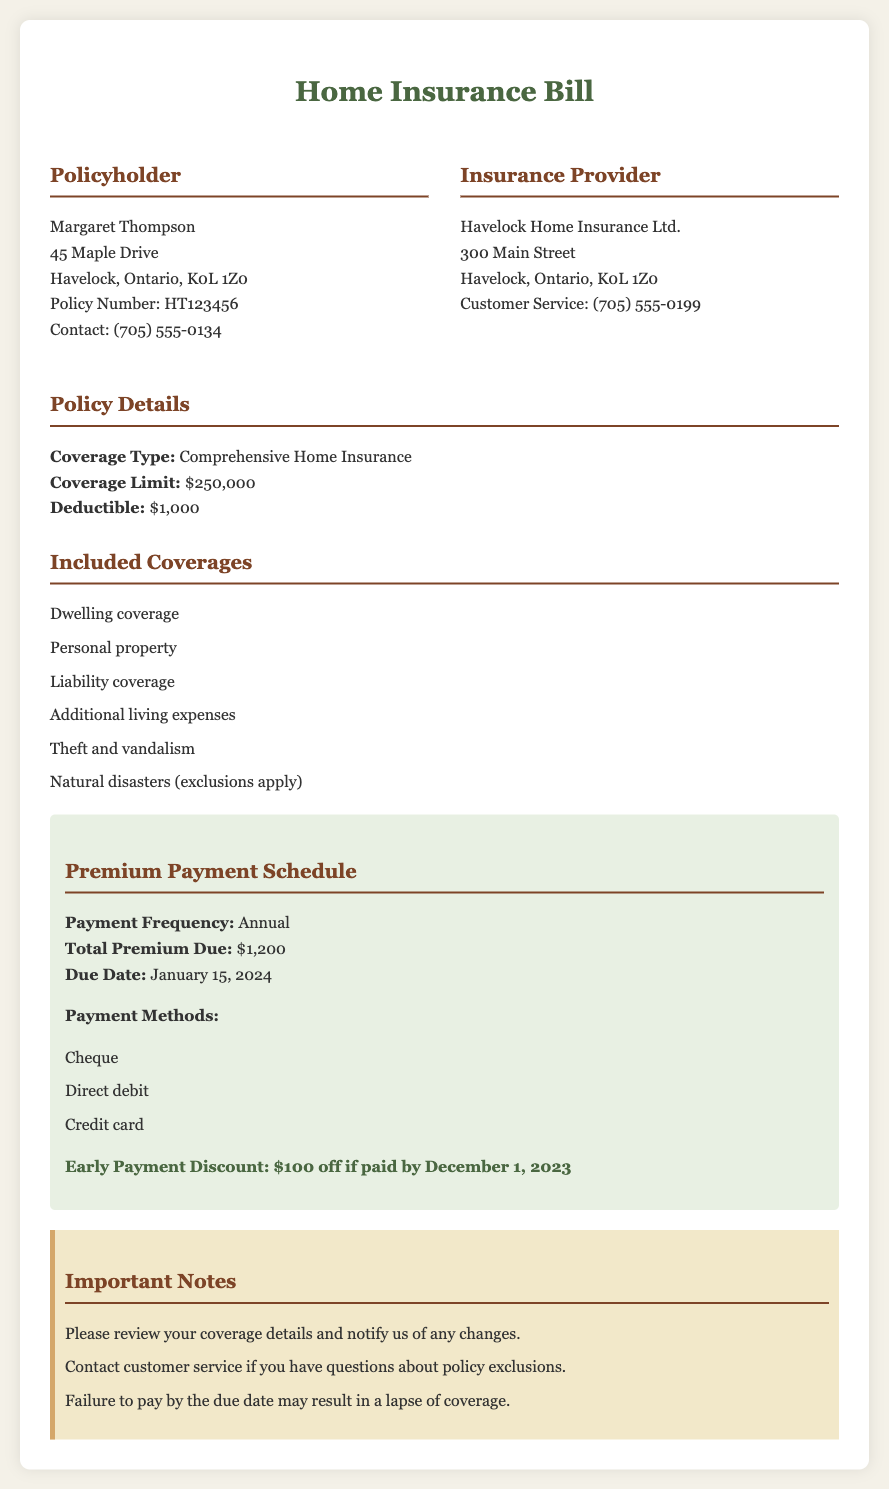What is the name of the policyholder? The policyholder's name is indicated at the top section of the document.
Answer: Margaret Thompson What is the coverage limit? The coverage limit is specified under the policy details section.
Answer: $250,000 What is the deductible amount? The deductible amount is listed under the policy details section.
Answer: $1,000 When is the premium due date? The due date for the total premium payment is explicitly stated in the premium payment schedule.
Answer: January 15, 2024 What is the total premium due? The total premium due is mentioned in the payment schedule section.
Answer: $1,200 How much is the early payment discount? The early payment discount is noted in the premium payment schedule.
Answer: $100 What types of coverages are included? The types of coverages are listed in the included coverages section.
Answer: Dwelling coverage, Personal property, Liability coverage, Additional living expenses, Theft and vandalism, Natural disasters (exclusions apply) What payment methods are accepted? The payment methods are outlined in the payment schedule section.
Answer: Cheque, Direct debit, Credit card What should you do if there are changes to your coverage? The document provides guidance in the important notes section regarding coverage changes.
Answer: Notify us of any changes 